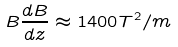Convert formula to latex. <formula><loc_0><loc_0><loc_500><loc_500>B \frac { d B } { d z } \approx 1 4 0 0 T ^ { 2 } / m</formula> 